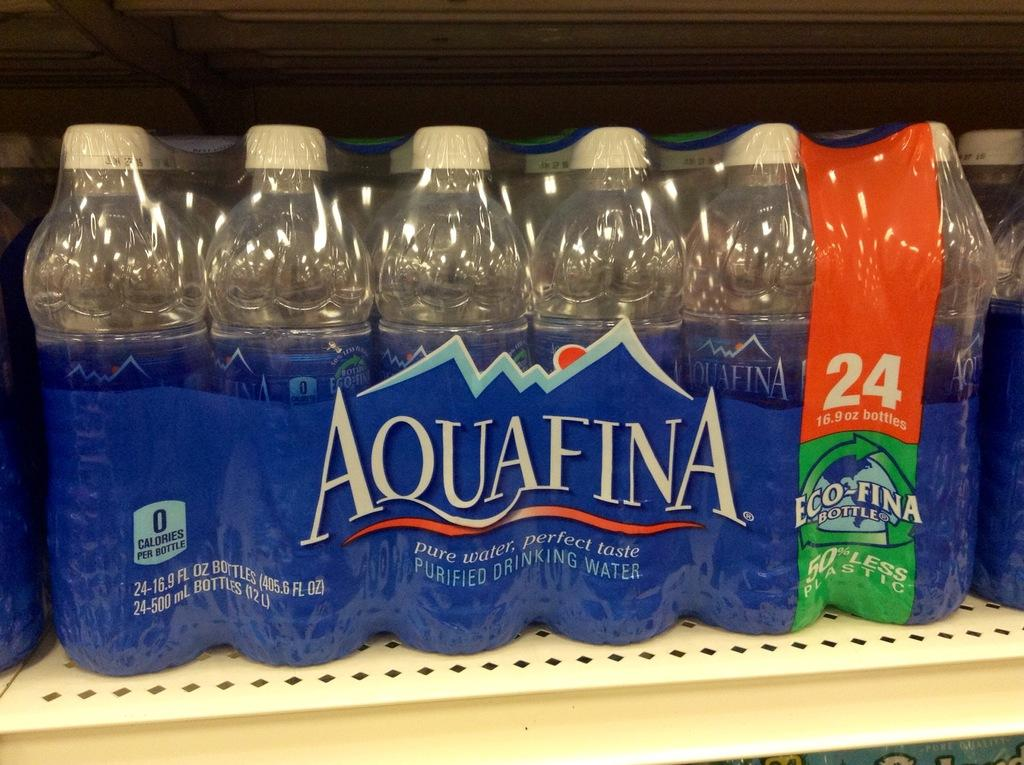<image>
Write a terse but informative summary of the picture. The pack shown on the shelf contains 24 bottles of water. 